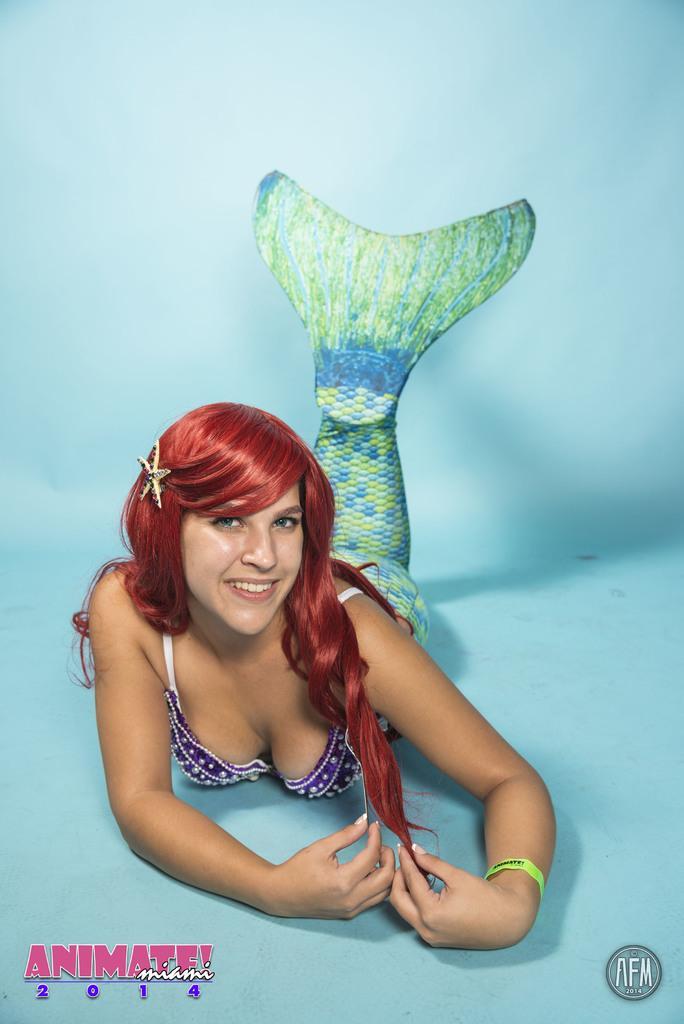Please provide a concise description of this image. In this image we can see a lady is lying on the floor. The floor is completely painted with blue color. 